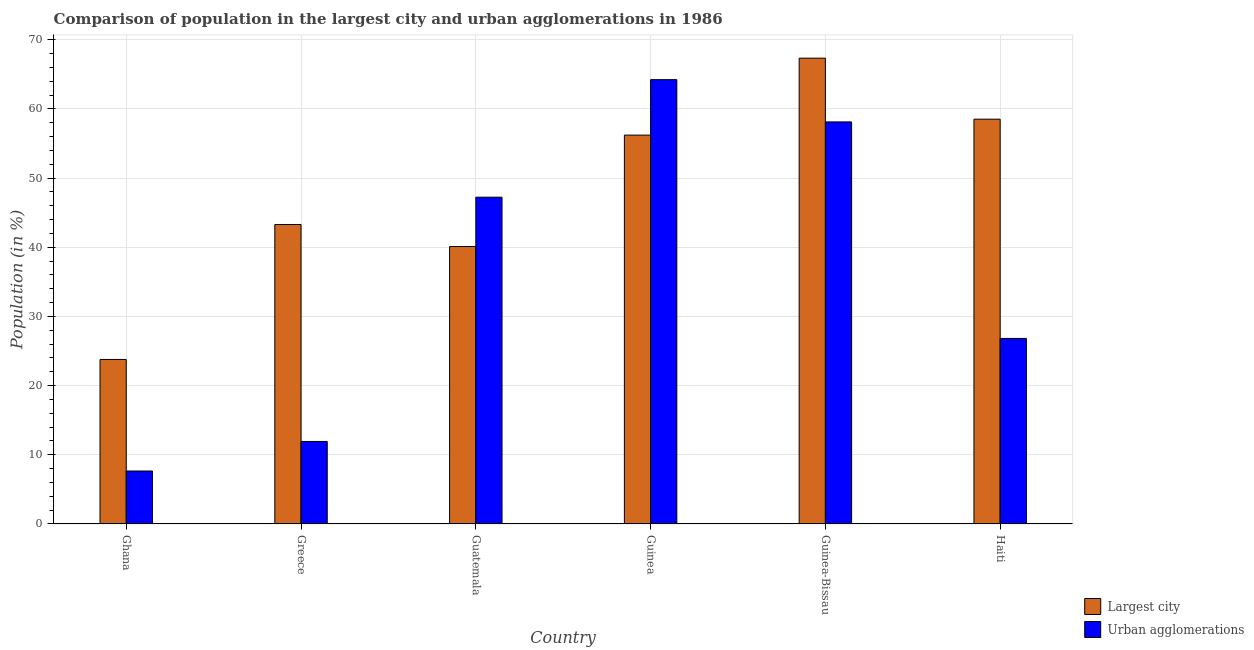Are the number of bars per tick equal to the number of legend labels?
Your response must be concise. Yes. Are the number of bars on each tick of the X-axis equal?
Offer a very short reply. Yes. How many bars are there on the 1st tick from the left?
Keep it short and to the point. 2. How many bars are there on the 3rd tick from the right?
Your response must be concise. 2. In how many cases, is the number of bars for a given country not equal to the number of legend labels?
Your answer should be compact. 0. What is the population in the largest city in Haiti?
Provide a short and direct response. 58.52. Across all countries, what is the maximum population in urban agglomerations?
Offer a very short reply. 64.24. Across all countries, what is the minimum population in the largest city?
Provide a succinct answer. 23.79. In which country was the population in the largest city maximum?
Your response must be concise. Guinea-Bissau. In which country was the population in urban agglomerations minimum?
Your answer should be compact. Ghana. What is the total population in the largest city in the graph?
Provide a short and direct response. 289.27. What is the difference between the population in urban agglomerations in Greece and that in Guinea-Bissau?
Keep it short and to the point. -46.2. What is the difference between the population in urban agglomerations in Haiti and the population in the largest city in Guinea-Bissau?
Your response must be concise. -40.52. What is the average population in urban agglomerations per country?
Ensure brevity in your answer.  36. What is the difference between the population in urban agglomerations and population in the largest city in Guinea?
Your answer should be compact. 8.02. In how many countries, is the population in urban agglomerations greater than 68 %?
Give a very brief answer. 0. What is the ratio of the population in the largest city in Ghana to that in Guatemala?
Give a very brief answer. 0.59. Is the population in the largest city in Ghana less than that in Greece?
Offer a very short reply. Yes. What is the difference between the highest and the second highest population in urban agglomerations?
Keep it short and to the point. 6.11. What is the difference between the highest and the lowest population in urban agglomerations?
Ensure brevity in your answer.  56.58. What does the 1st bar from the left in Haiti represents?
Your response must be concise. Largest city. What does the 2nd bar from the right in Haiti represents?
Ensure brevity in your answer.  Largest city. How many countries are there in the graph?
Make the answer very short. 6. What is the difference between two consecutive major ticks on the Y-axis?
Your answer should be very brief. 10. Does the graph contain any zero values?
Your answer should be very brief. No. Does the graph contain grids?
Keep it short and to the point. Yes. How many legend labels are there?
Your response must be concise. 2. How are the legend labels stacked?
Offer a terse response. Vertical. What is the title of the graph?
Offer a very short reply. Comparison of population in the largest city and urban agglomerations in 1986. Does "Highest 10% of population" appear as one of the legend labels in the graph?
Make the answer very short. No. What is the Population (in %) of Largest city in Ghana?
Ensure brevity in your answer.  23.79. What is the Population (in %) of Urban agglomerations in Ghana?
Provide a short and direct response. 7.66. What is the Population (in %) of Largest city in Greece?
Provide a short and direct response. 43.29. What is the Population (in %) of Urban agglomerations in Greece?
Offer a very short reply. 11.93. What is the Population (in %) of Largest city in Guatemala?
Give a very brief answer. 40.11. What is the Population (in %) in Urban agglomerations in Guatemala?
Make the answer very short. 47.24. What is the Population (in %) in Largest city in Guinea?
Give a very brief answer. 56.22. What is the Population (in %) of Urban agglomerations in Guinea?
Offer a very short reply. 64.24. What is the Population (in %) of Largest city in Guinea-Bissau?
Make the answer very short. 67.34. What is the Population (in %) of Urban agglomerations in Guinea-Bissau?
Offer a terse response. 58.13. What is the Population (in %) of Largest city in Haiti?
Give a very brief answer. 58.52. What is the Population (in %) in Urban agglomerations in Haiti?
Provide a short and direct response. 26.83. Across all countries, what is the maximum Population (in %) in Largest city?
Provide a short and direct response. 67.34. Across all countries, what is the maximum Population (in %) of Urban agglomerations?
Your answer should be very brief. 64.24. Across all countries, what is the minimum Population (in %) of Largest city?
Your answer should be compact. 23.79. Across all countries, what is the minimum Population (in %) in Urban agglomerations?
Keep it short and to the point. 7.66. What is the total Population (in %) of Largest city in the graph?
Ensure brevity in your answer.  289.27. What is the total Population (in %) in Urban agglomerations in the graph?
Offer a very short reply. 216.02. What is the difference between the Population (in %) in Largest city in Ghana and that in Greece?
Offer a terse response. -19.51. What is the difference between the Population (in %) of Urban agglomerations in Ghana and that in Greece?
Ensure brevity in your answer.  -4.27. What is the difference between the Population (in %) in Largest city in Ghana and that in Guatemala?
Offer a very short reply. -16.32. What is the difference between the Population (in %) of Urban agglomerations in Ghana and that in Guatemala?
Your answer should be compact. -39.58. What is the difference between the Population (in %) of Largest city in Ghana and that in Guinea?
Your answer should be compact. -32.43. What is the difference between the Population (in %) in Urban agglomerations in Ghana and that in Guinea?
Your answer should be compact. -56.58. What is the difference between the Population (in %) in Largest city in Ghana and that in Guinea-Bissau?
Keep it short and to the point. -43.56. What is the difference between the Population (in %) in Urban agglomerations in Ghana and that in Guinea-Bissau?
Your answer should be compact. -50.47. What is the difference between the Population (in %) in Largest city in Ghana and that in Haiti?
Offer a very short reply. -34.74. What is the difference between the Population (in %) of Urban agglomerations in Ghana and that in Haiti?
Ensure brevity in your answer.  -19.17. What is the difference between the Population (in %) in Largest city in Greece and that in Guatemala?
Keep it short and to the point. 3.18. What is the difference between the Population (in %) of Urban agglomerations in Greece and that in Guatemala?
Keep it short and to the point. -35.31. What is the difference between the Population (in %) of Largest city in Greece and that in Guinea?
Offer a terse response. -12.92. What is the difference between the Population (in %) of Urban agglomerations in Greece and that in Guinea?
Your response must be concise. -52.31. What is the difference between the Population (in %) of Largest city in Greece and that in Guinea-Bissau?
Offer a very short reply. -24.05. What is the difference between the Population (in %) in Urban agglomerations in Greece and that in Guinea-Bissau?
Your answer should be compact. -46.2. What is the difference between the Population (in %) of Largest city in Greece and that in Haiti?
Your response must be concise. -15.23. What is the difference between the Population (in %) of Urban agglomerations in Greece and that in Haiti?
Keep it short and to the point. -14.89. What is the difference between the Population (in %) of Largest city in Guatemala and that in Guinea?
Give a very brief answer. -16.11. What is the difference between the Population (in %) in Urban agglomerations in Guatemala and that in Guinea?
Keep it short and to the point. -17. What is the difference between the Population (in %) in Largest city in Guatemala and that in Guinea-Bissau?
Your response must be concise. -27.23. What is the difference between the Population (in %) of Urban agglomerations in Guatemala and that in Guinea-Bissau?
Make the answer very short. -10.88. What is the difference between the Population (in %) of Largest city in Guatemala and that in Haiti?
Offer a terse response. -18.41. What is the difference between the Population (in %) in Urban agglomerations in Guatemala and that in Haiti?
Your answer should be very brief. 20.42. What is the difference between the Population (in %) in Largest city in Guinea and that in Guinea-Bissau?
Provide a succinct answer. -11.12. What is the difference between the Population (in %) of Urban agglomerations in Guinea and that in Guinea-Bissau?
Your answer should be very brief. 6.11. What is the difference between the Population (in %) of Largest city in Guinea and that in Haiti?
Make the answer very short. -2.3. What is the difference between the Population (in %) of Urban agglomerations in Guinea and that in Haiti?
Ensure brevity in your answer.  37.41. What is the difference between the Population (in %) of Largest city in Guinea-Bissau and that in Haiti?
Ensure brevity in your answer.  8.82. What is the difference between the Population (in %) of Urban agglomerations in Guinea-Bissau and that in Haiti?
Offer a very short reply. 31.3. What is the difference between the Population (in %) in Largest city in Ghana and the Population (in %) in Urban agglomerations in Greece?
Offer a terse response. 11.86. What is the difference between the Population (in %) in Largest city in Ghana and the Population (in %) in Urban agglomerations in Guatemala?
Provide a short and direct response. -23.46. What is the difference between the Population (in %) in Largest city in Ghana and the Population (in %) in Urban agglomerations in Guinea?
Ensure brevity in your answer.  -40.45. What is the difference between the Population (in %) in Largest city in Ghana and the Population (in %) in Urban agglomerations in Guinea-Bissau?
Provide a short and direct response. -34.34. What is the difference between the Population (in %) in Largest city in Ghana and the Population (in %) in Urban agglomerations in Haiti?
Your answer should be compact. -3.04. What is the difference between the Population (in %) of Largest city in Greece and the Population (in %) of Urban agglomerations in Guatemala?
Provide a short and direct response. -3.95. What is the difference between the Population (in %) of Largest city in Greece and the Population (in %) of Urban agglomerations in Guinea?
Your response must be concise. -20.94. What is the difference between the Population (in %) in Largest city in Greece and the Population (in %) in Urban agglomerations in Guinea-Bissau?
Keep it short and to the point. -14.83. What is the difference between the Population (in %) of Largest city in Greece and the Population (in %) of Urban agglomerations in Haiti?
Keep it short and to the point. 16.47. What is the difference between the Population (in %) of Largest city in Guatemala and the Population (in %) of Urban agglomerations in Guinea?
Provide a short and direct response. -24.13. What is the difference between the Population (in %) of Largest city in Guatemala and the Population (in %) of Urban agglomerations in Guinea-Bissau?
Your answer should be compact. -18.02. What is the difference between the Population (in %) of Largest city in Guatemala and the Population (in %) of Urban agglomerations in Haiti?
Offer a very short reply. 13.29. What is the difference between the Population (in %) in Largest city in Guinea and the Population (in %) in Urban agglomerations in Guinea-Bissau?
Ensure brevity in your answer.  -1.91. What is the difference between the Population (in %) in Largest city in Guinea and the Population (in %) in Urban agglomerations in Haiti?
Offer a terse response. 29.39. What is the difference between the Population (in %) in Largest city in Guinea-Bissau and the Population (in %) in Urban agglomerations in Haiti?
Offer a very short reply. 40.52. What is the average Population (in %) of Largest city per country?
Offer a terse response. 48.21. What is the average Population (in %) in Urban agglomerations per country?
Give a very brief answer. 36. What is the difference between the Population (in %) of Largest city and Population (in %) of Urban agglomerations in Ghana?
Offer a terse response. 16.13. What is the difference between the Population (in %) in Largest city and Population (in %) in Urban agglomerations in Greece?
Offer a very short reply. 31.36. What is the difference between the Population (in %) in Largest city and Population (in %) in Urban agglomerations in Guatemala?
Your response must be concise. -7.13. What is the difference between the Population (in %) of Largest city and Population (in %) of Urban agglomerations in Guinea?
Provide a succinct answer. -8.02. What is the difference between the Population (in %) in Largest city and Population (in %) in Urban agglomerations in Guinea-Bissau?
Offer a terse response. 9.22. What is the difference between the Population (in %) in Largest city and Population (in %) in Urban agglomerations in Haiti?
Your response must be concise. 31.7. What is the ratio of the Population (in %) in Largest city in Ghana to that in Greece?
Make the answer very short. 0.55. What is the ratio of the Population (in %) in Urban agglomerations in Ghana to that in Greece?
Keep it short and to the point. 0.64. What is the ratio of the Population (in %) of Largest city in Ghana to that in Guatemala?
Give a very brief answer. 0.59. What is the ratio of the Population (in %) in Urban agglomerations in Ghana to that in Guatemala?
Your answer should be compact. 0.16. What is the ratio of the Population (in %) of Largest city in Ghana to that in Guinea?
Your response must be concise. 0.42. What is the ratio of the Population (in %) of Urban agglomerations in Ghana to that in Guinea?
Provide a short and direct response. 0.12. What is the ratio of the Population (in %) in Largest city in Ghana to that in Guinea-Bissau?
Ensure brevity in your answer.  0.35. What is the ratio of the Population (in %) of Urban agglomerations in Ghana to that in Guinea-Bissau?
Keep it short and to the point. 0.13. What is the ratio of the Population (in %) of Largest city in Ghana to that in Haiti?
Offer a very short reply. 0.41. What is the ratio of the Population (in %) of Urban agglomerations in Ghana to that in Haiti?
Your answer should be compact. 0.29. What is the ratio of the Population (in %) of Largest city in Greece to that in Guatemala?
Ensure brevity in your answer.  1.08. What is the ratio of the Population (in %) of Urban agglomerations in Greece to that in Guatemala?
Provide a succinct answer. 0.25. What is the ratio of the Population (in %) in Largest city in Greece to that in Guinea?
Your answer should be compact. 0.77. What is the ratio of the Population (in %) of Urban agglomerations in Greece to that in Guinea?
Your answer should be compact. 0.19. What is the ratio of the Population (in %) in Largest city in Greece to that in Guinea-Bissau?
Your response must be concise. 0.64. What is the ratio of the Population (in %) of Urban agglomerations in Greece to that in Guinea-Bissau?
Ensure brevity in your answer.  0.21. What is the ratio of the Population (in %) of Largest city in Greece to that in Haiti?
Offer a terse response. 0.74. What is the ratio of the Population (in %) in Urban agglomerations in Greece to that in Haiti?
Make the answer very short. 0.44. What is the ratio of the Population (in %) in Largest city in Guatemala to that in Guinea?
Provide a succinct answer. 0.71. What is the ratio of the Population (in %) in Urban agglomerations in Guatemala to that in Guinea?
Your answer should be very brief. 0.74. What is the ratio of the Population (in %) in Largest city in Guatemala to that in Guinea-Bissau?
Make the answer very short. 0.6. What is the ratio of the Population (in %) of Urban agglomerations in Guatemala to that in Guinea-Bissau?
Give a very brief answer. 0.81. What is the ratio of the Population (in %) in Largest city in Guatemala to that in Haiti?
Your answer should be very brief. 0.69. What is the ratio of the Population (in %) in Urban agglomerations in Guatemala to that in Haiti?
Provide a short and direct response. 1.76. What is the ratio of the Population (in %) in Largest city in Guinea to that in Guinea-Bissau?
Your answer should be compact. 0.83. What is the ratio of the Population (in %) of Urban agglomerations in Guinea to that in Guinea-Bissau?
Provide a short and direct response. 1.11. What is the ratio of the Population (in %) of Largest city in Guinea to that in Haiti?
Offer a terse response. 0.96. What is the ratio of the Population (in %) in Urban agglomerations in Guinea to that in Haiti?
Keep it short and to the point. 2.39. What is the ratio of the Population (in %) in Largest city in Guinea-Bissau to that in Haiti?
Provide a short and direct response. 1.15. What is the ratio of the Population (in %) of Urban agglomerations in Guinea-Bissau to that in Haiti?
Provide a short and direct response. 2.17. What is the difference between the highest and the second highest Population (in %) of Largest city?
Your answer should be very brief. 8.82. What is the difference between the highest and the second highest Population (in %) in Urban agglomerations?
Offer a very short reply. 6.11. What is the difference between the highest and the lowest Population (in %) in Largest city?
Your response must be concise. 43.56. What is the difference between the highest and the lowest Population (in %) in Urban agglomerations?
Give a very brief answer. 56.58. 